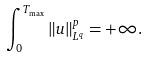Convert formula to latex. <formula><loc_0><loc_0><loc_500><loc_500>\int _ { 0 } ^ { T _ { \max } } \| u \| _ { L ^ { q } } ^ { p } = + \infty .</formula> 